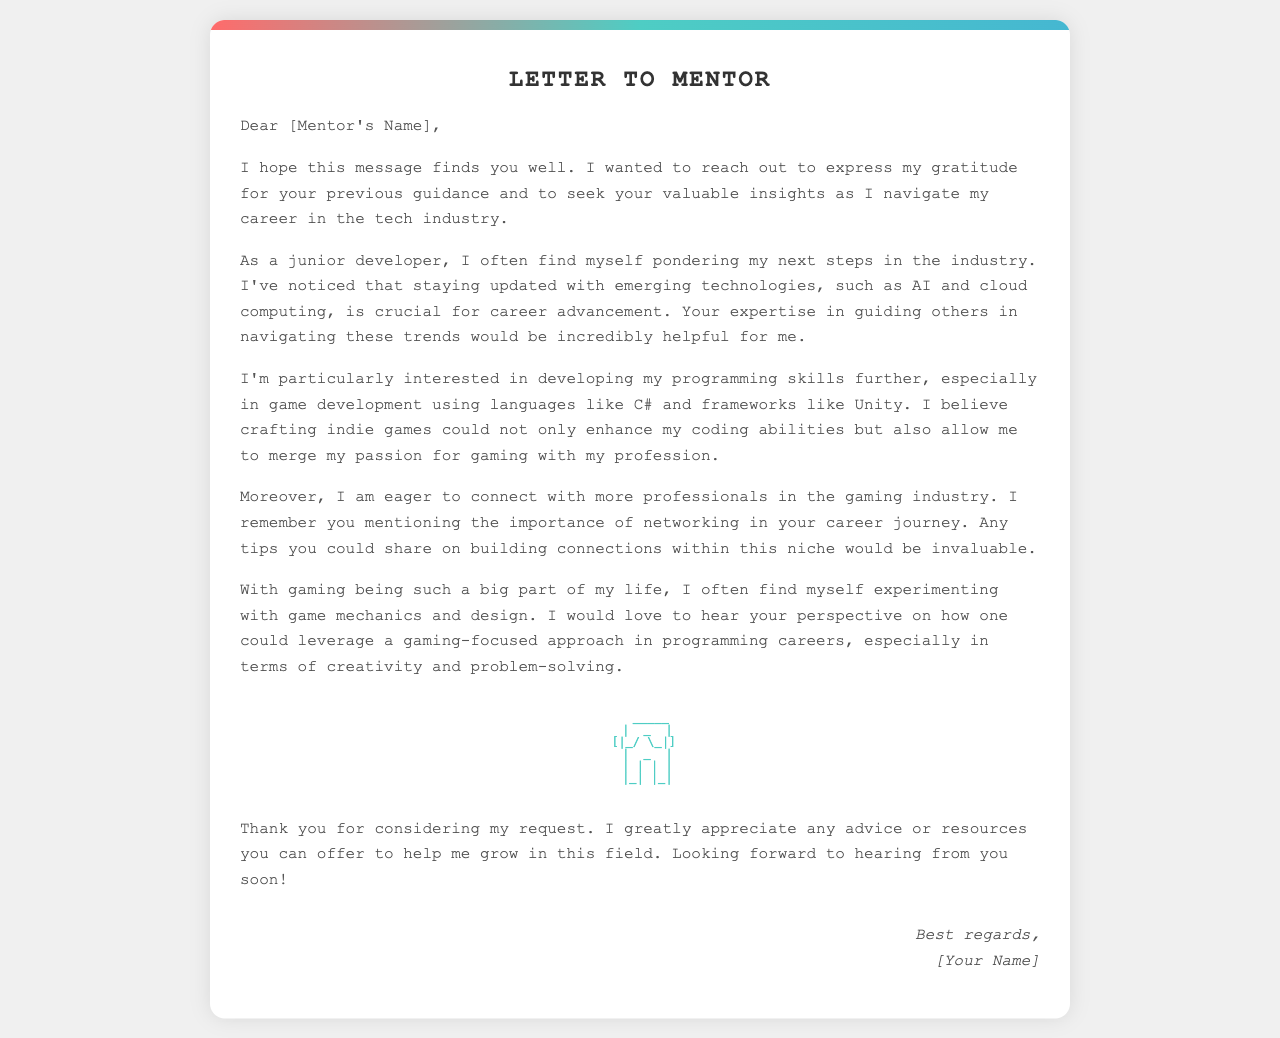What is the main purpose of the letter? The letter expresses gratitude and requests guidance on career growth and skills development.
Answer: guidance Who is the letter addressed to? The letter is addressed to a mentor, referred to as [Mentor's Name].
Answer: [Mentor's Name] What programming language is mentioned for game development? The letter mentions C# as the programming language of interest for game development.
Answer: C# Which game development framework does the author want to use? The author expresses interest in using Unity as the game development framework.
Answer: Unity What does the author want to enhance by crafting indie games? The author believes crafting indie games could enhance their coding abilities.
Answer: coding abilities What area of the tech industry does the author express eagerness to connect with professionals? The author wants to connect with professionals in the gaming industry.
Answer: gaming industry What aspect of their current situation is the author pondering? The author is pondering their next steps in the tech industry.
Answer: next steps What does the author remember about networking? The author recalls that networking is important, as mentioned by the mentor.
Answer: important What type of approach does the author want to leverage in programming careers? The author wants to leverage a gaming-focused approach in programming careers.
Answer: gaming-focused approach 